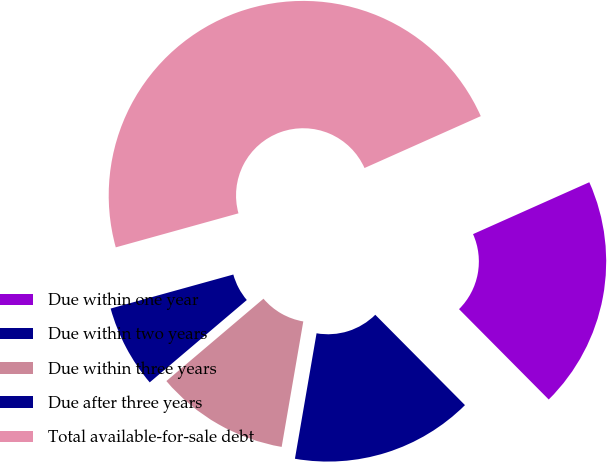Convert chart. <chart><loc_0><loc_0><loc_500><loc_500><pie_chart><fcel>Due within one year<fcel>Due within two years<fcel>Due within three years<fcel>Due after three years<fcel>Total available-for-sale debt<nl><fcel>19.24%<fcel>15.16%<fcel>11.09%<fcel>6.89%<fcel>47.63%<nl></chart> 